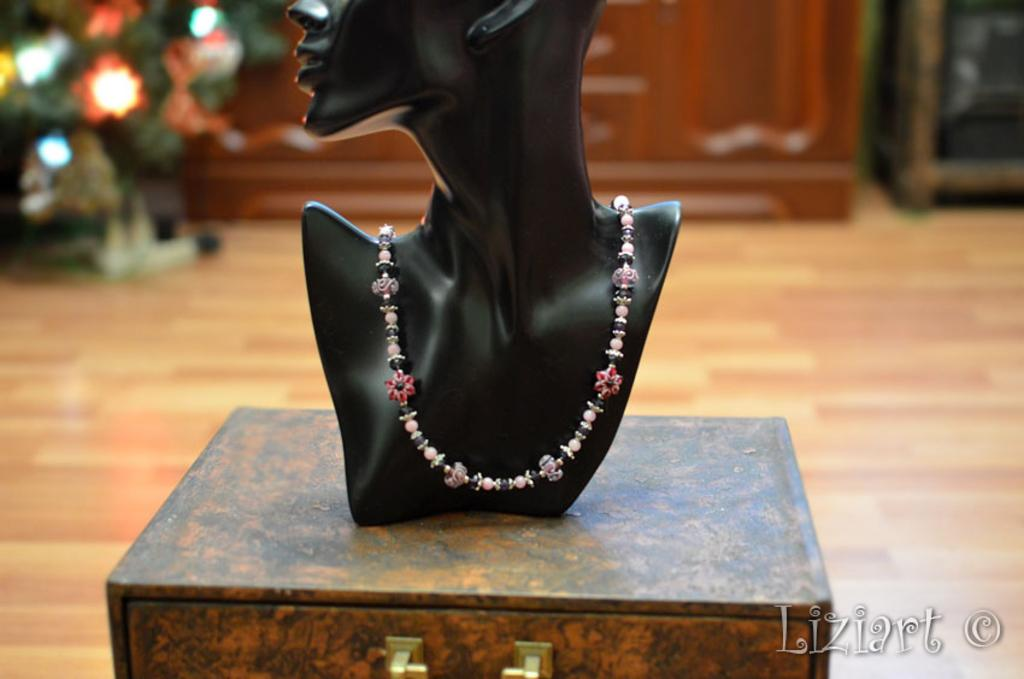What is the main subject in the image? There is a mannequin in the image. What is the mannequin wearing? The mannequin is wearing a chain. Where is the mannequin located? The mannequin is on a table. What is the color of the table? The table is brown in color. What can be seen in the background of the image? There is a wooden cupboard in the background of the image. What is the color of the wooden cupboard? The wooden cupboard is brown in color. How many ladybugs are crawling on the mannequin in the image? There are no ladybugs present in the image; it only features a mannequin wearing a chain on a brown table. What type of stamp is visible on the mannequin's hand in the image? There is no stamp visible on the mannequin's hand in the image. 